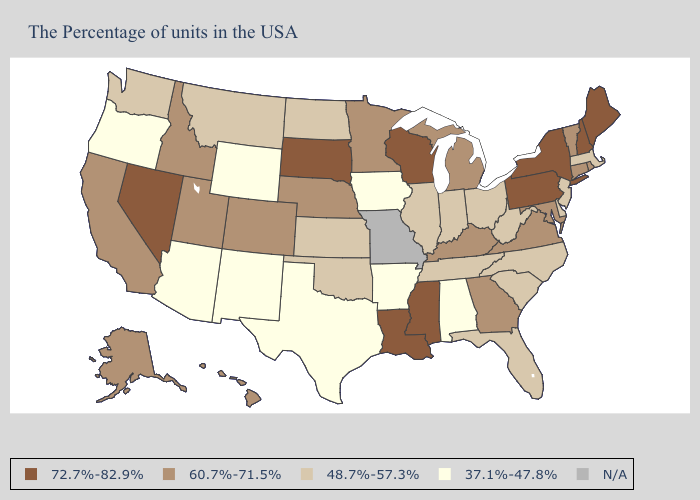Name the states that have a value in the range 48.7%-57.3%?
Quick response, please. Massachusetts, New Jersey, Delaware, North Carolina, South Carolina, West Virginia, Ohio, Florida, Indiana, Tennessee, Illinois, Kansas, Oklahoma, North Dakota, Montana, Washington. What is the lowest value in the Northeast?
Quick response, please. 48.7%-57.3%. Does the map have missing data?
Keep it brief. Yes. What is the value of Mississippi?
Give a very brief answer. 72.7%-82.9%. Among the states that border Colorado , does Wyoming have the lowest value?
Give a very brief answer. Yes. What is the value of Minnesota?
Give a very brief answer. 60.7%-71.5%. Name the states that have a value in the range N/A?
Keep it brief. Missouri. Name the states that have a value in the range 37.1%-47.8%?
Give a very brief answer. Alabama, Arkansas, Iowa, Texas, Wyoming, New Mexico, Arizona, Oregon. What is the value of North Carolina?
Be succinct. 48.7%-57.3%. Name the states that have a value in the range 72.7%-82.9%?
Quick response, please. Maine, New Hampshire, New York, Pennsylvania, Wisconsin, Mississippi, Louisiana, South Dakota, Nevada. What is the value of Wyoming?
Keep it brief. 37.1%-47.8%. What is the value of Missouri?
Short answer required. N/A. Name the states that have a value in the range 48.7%-57.3%?
Concise answer only. Massachusetts, New Jersey, Delaware, North Carolina, South Carolina, West Virginia, Ohio, Florida, Indiana, Tennessee, Illinois, Kansas, Oklahoma, North Dakota, Montana, Washington. Name the states that have a value in the range 48.7%-57.3%?
Be succinct. Massachusetts, New Jersey, Delaware, North Carolina, South Carolina, West Virginia, Ohio, Florida, Indiana, Tennessee, Illinois, Kansas, Oklahoma, North Dakota, Montana, Washington. 